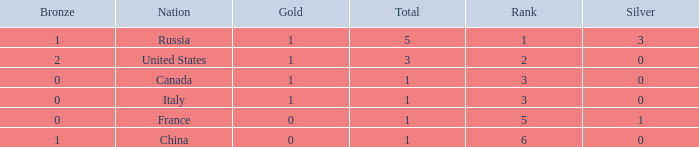Write the full table. {'header': ['Bronze', 'Nation', 'Gold', 'Total', 'Rank', 'Silver'], 'rows': [['1', 'Russia', '1', '5', '1', '3'], ['2', 'United States', '1', '3', '2', '0'], ['0', 'Canada', '1', '1', '3', '0'], ['0', 'Italy', '1', '1', '3', '0'], ['0', 'France', '0', '1', '5', '1'], ['1', 'China', '0', '1', '6', '0']]} Name the total number of golds when total is 1 and silver is 1 1.0. 